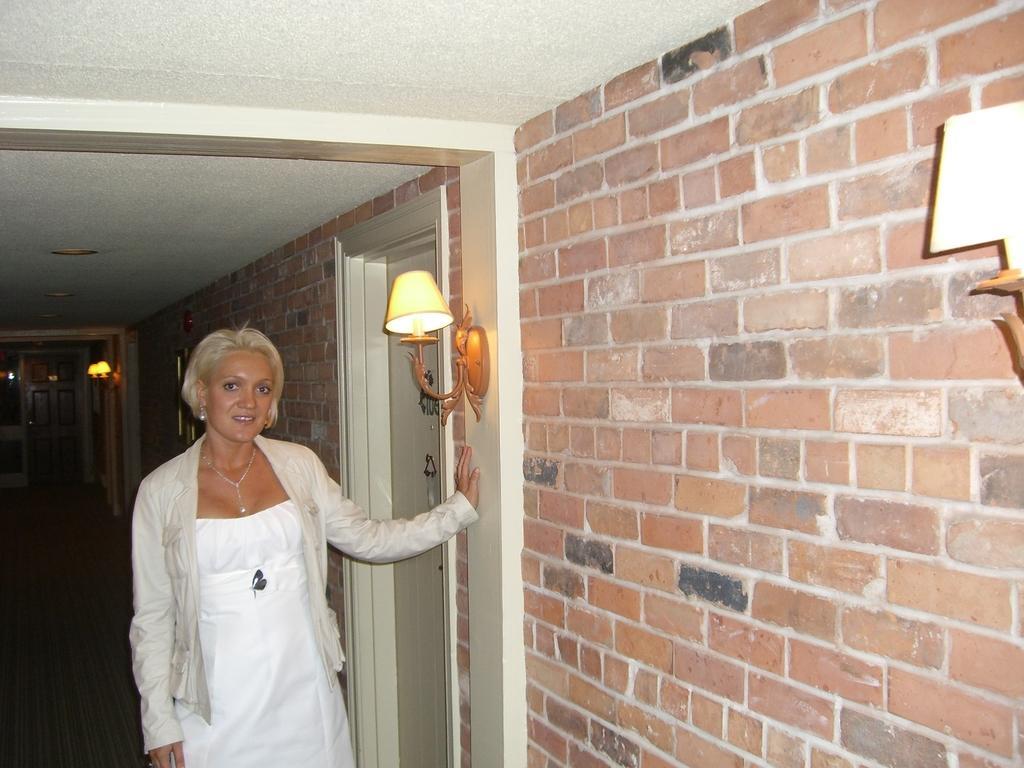Please provide a concise description of this image. In the picture there is a woman standing near the wall, there are lamps on the wall, there is a door. 